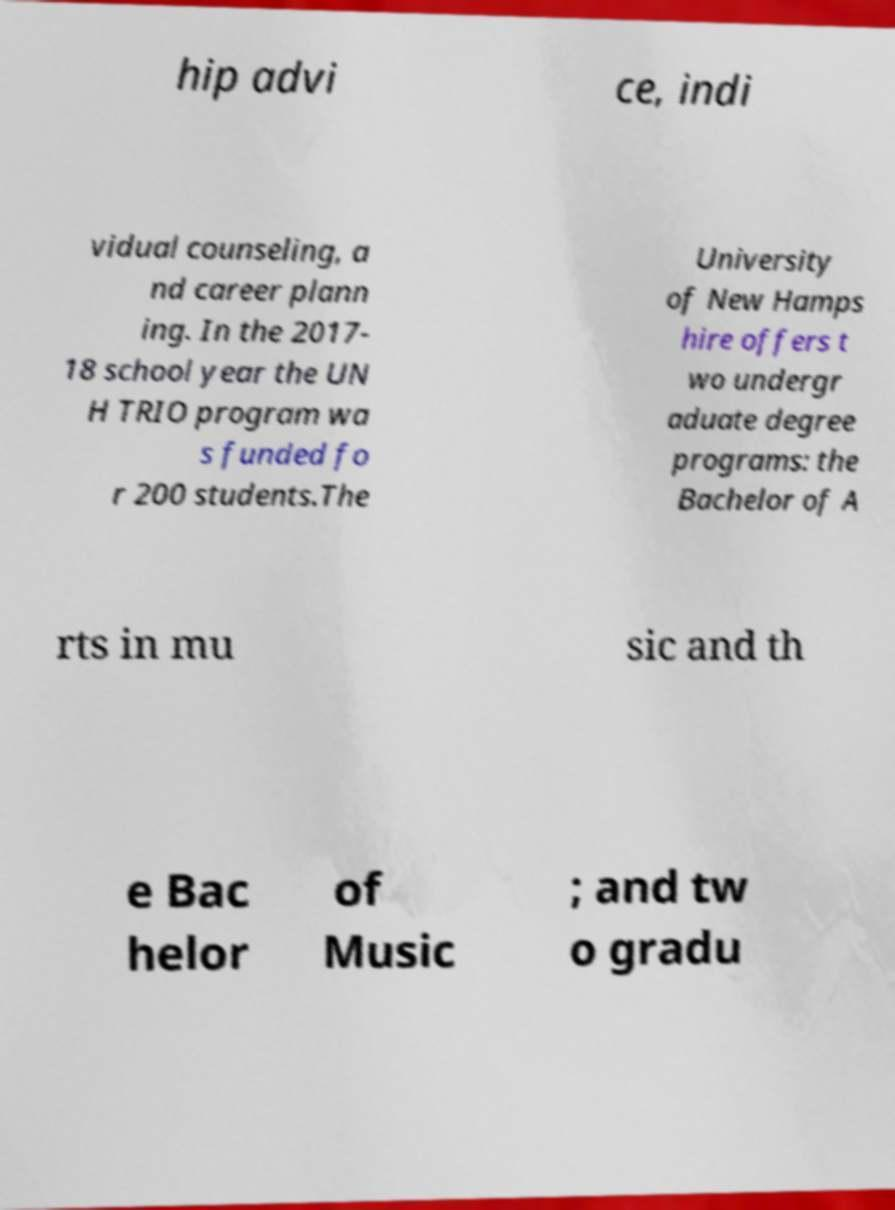Please read and relay the text visible in this image. What does it say? hip advi ce, indi vidual counseling, a nd career plann ing. In the 2017- 18 school year the UN H TRIO program wa s funded fo r 200 students.The University of New Hamps hire offers t wo undergr aduate degree programs: the Bachelor of A rts in mu sic and th e Bac helor of Music ; and tw o gradu 